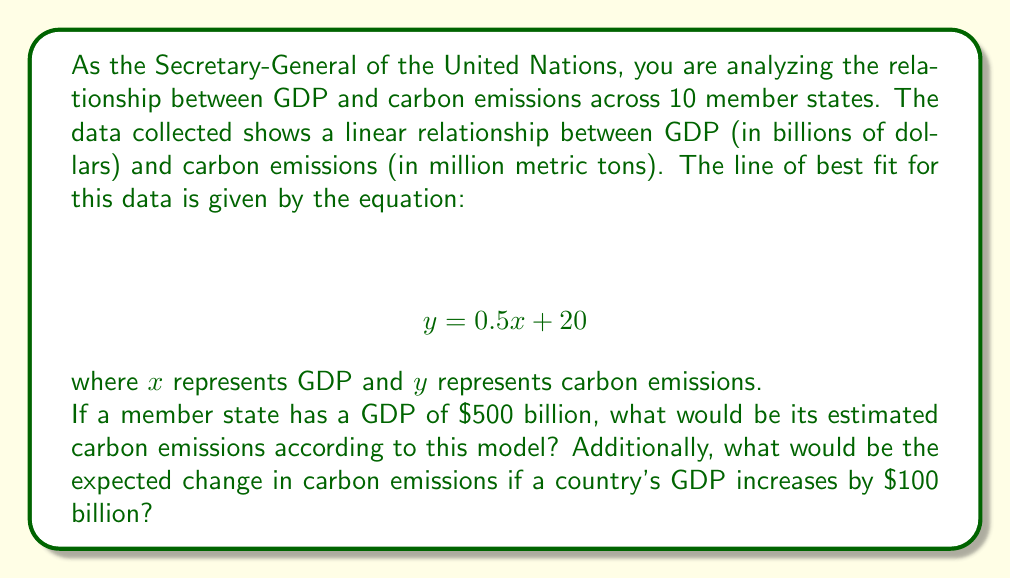Teach me how to tackle this problem. To solve this problem, we'll use the given linear equation and apply it to the specific scenarios:

1. Estimating carbon emissions for a GDP of $500 billion:
   We need to substitute $x = 500$ into the equation $y = 0.5x + 20$
   
   $y = 0.5(500) + 20$
   $y = 250 + 20$
   $y = 270$

2. Calculating the change in carbon emissions for a $100 billion increase in GDP:
   We can find this by calculating the slope of the line, which represents the rate of change.
   The slope is the coefficient of $x$ in the equation, which is 0.5.
   
   Change in emissions = 0.5 × Change in GDP
   Change in emissions = 0.5 × 100 = 50

Therefore, for every $100 billion increase in GDP, we expect a 50 million metric ton increase in carbon emissions according to this model.
Answer: 1. Estimated carbon emissions for a GDP of $500 billion: 270 million metric tons
2. Expected change in carbon emissions for a $100 billion increase in GDP: 50 million metric tons 